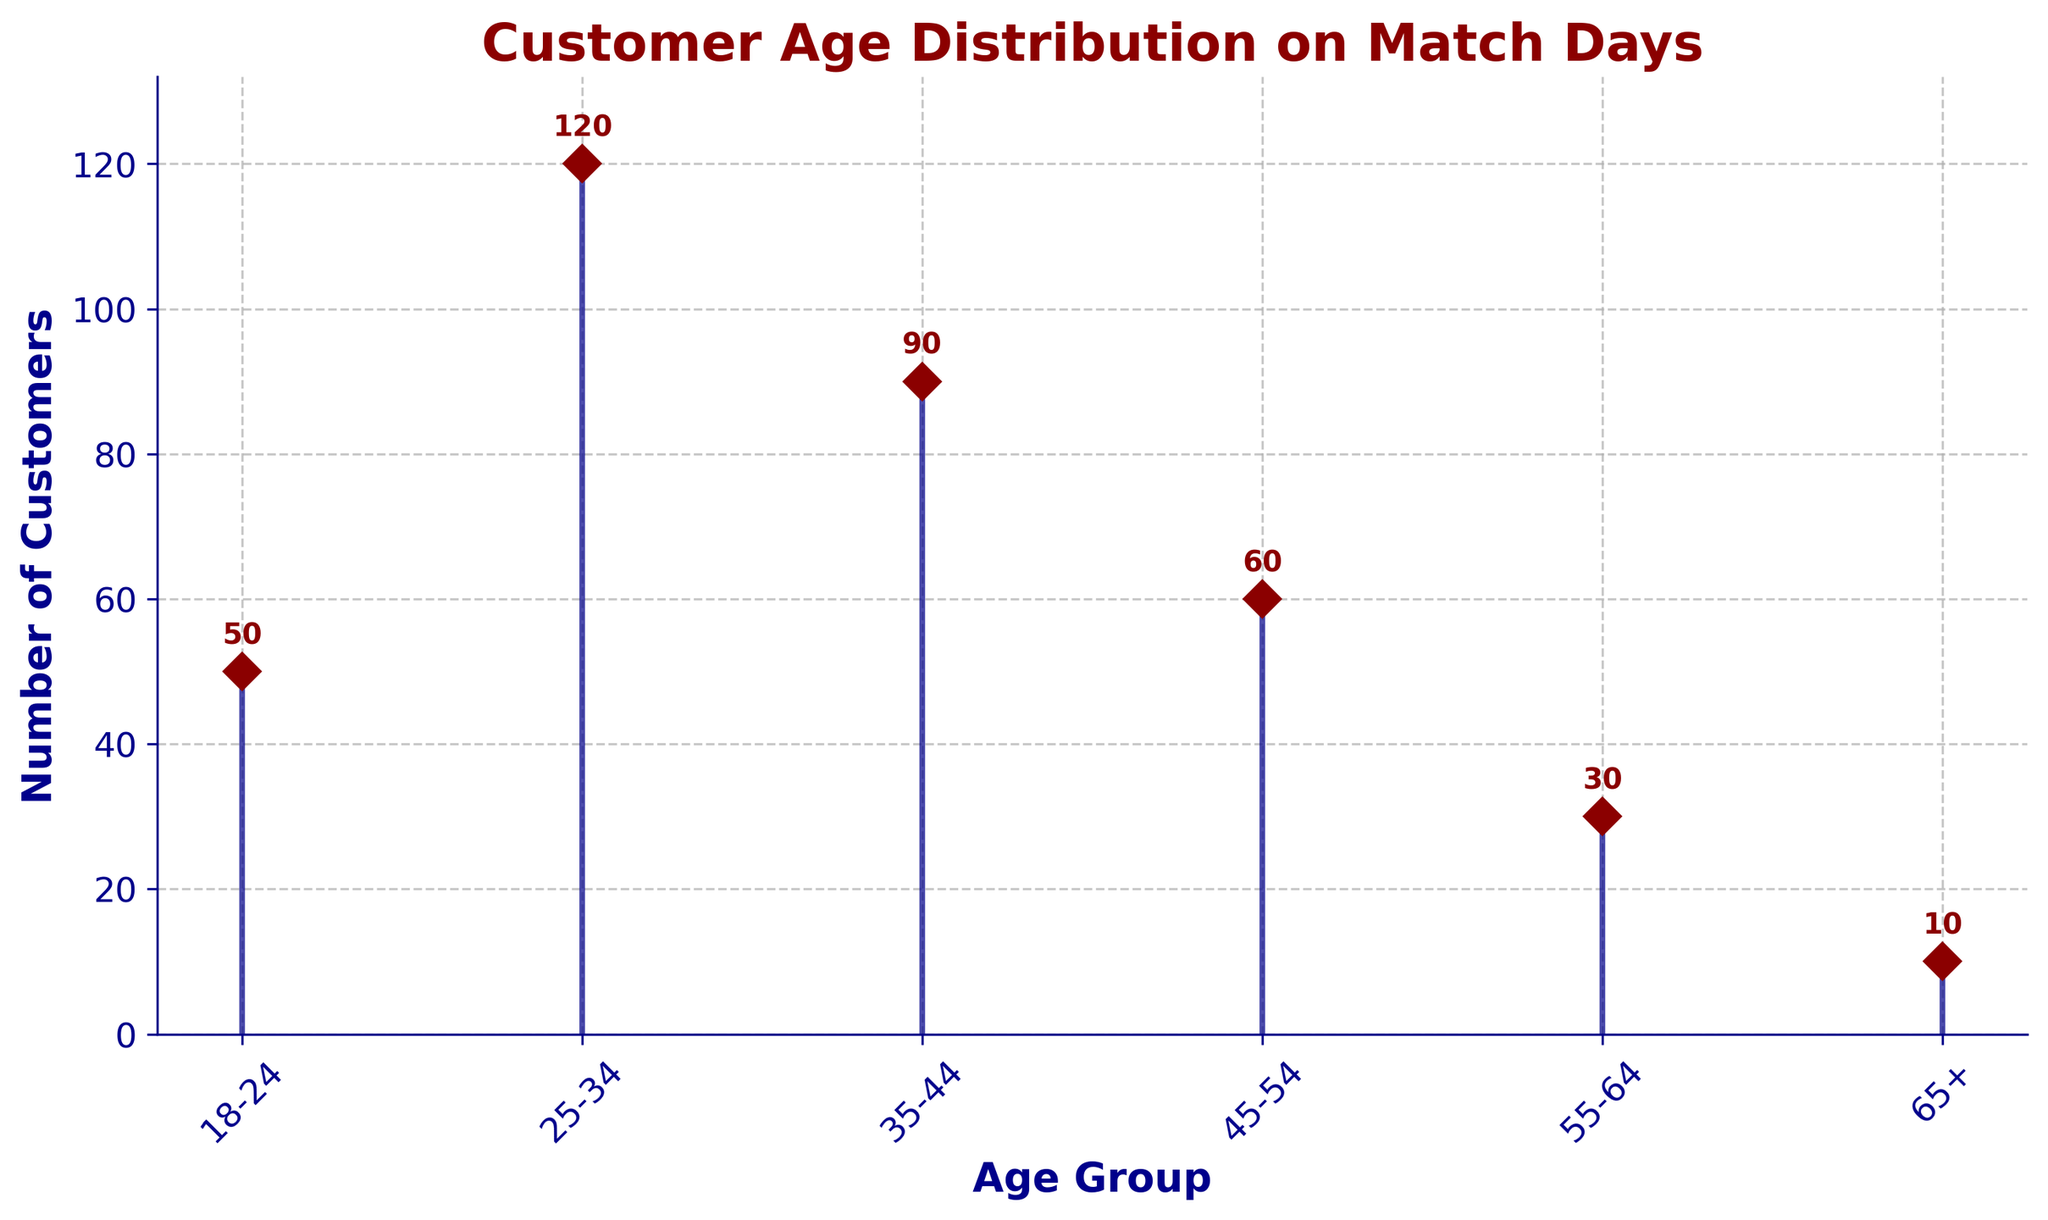What is the title of the plot? The title of the plot is displayed at the top of the figure in a bold and dark red font. It helps to understand the main focus of the data being presented.
Answer: Customer Age Distribution on Match Days What are the axis labels in the figure? The X-axis is labeled as 'Age Group' and the Y-axis is labeled as 'Number of Customers'. These labels help identify the type of data represented on each axis.
Answer: Age Group, Number of Customers How many age groups are represented in the plot? By counting the ticks on the X-axis, we can see there are six distinct age groups displayed in the figure.
Answer: 6 Which age group has the highest number of customers? By looking at the height of the stem lines, we can see that the '25-34' age group has the highest number of customers.
Answer: 25-34 What is the number of customers in the 65+ age group? The marker at the '65+' position indicates the number of customers, which is 10 according to the plot.
Answer: 10 What is the difference in the number of customers between the '25-34' and '35-44' age groups? Subtract the number of customers in the '35-44' age group (90) from the '25-34' age group (120). This gives 120 - 90 = 30.
Answer: 30 Which age groups have fewer than 50 customers each? By observing the height of the stem lines, the '18-24', '55-64', and '65+' age groups all have fewer than 50 customers each.
Answer: 18-24, 55-64, 65+ What is the combined number of customers in the '18-24' and '45-54' age groups? Add the number of customers in the '18-24' group (50) and the '45-54' group (60). This gives 50 + 60 = 110.
Answer: 110 What percentage of the total customers does the '35-44' age group represent? First, find the total number of customers by summing all groups: 50 + 120 + 90 + 60 + 30 + 10 = 360. Then, calculate the percentage: (90 / 360) * 100 = 25%.
Answer: 25% How does the number of customers in the '18-24' age group compare to the '55-64' age group? The '18-24' age group has 50 customers, while the '55-64' age group has 30 customers. Thus, the '18-24' group has more customers.
Answer: '18-24' has more customers 